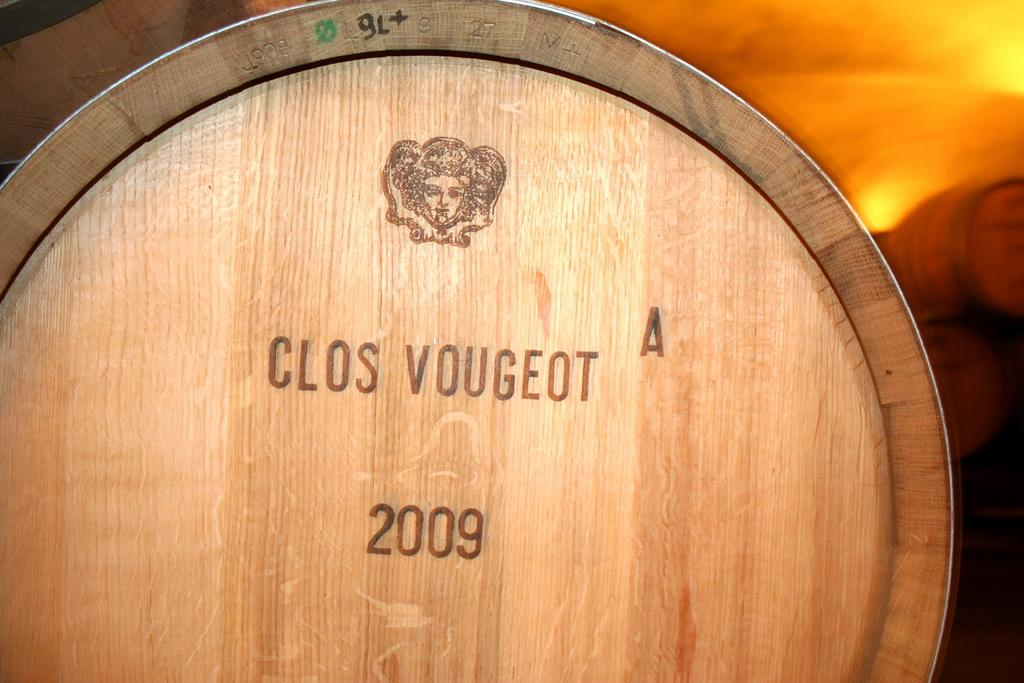<image>
Render a clear and concise summary of the photo. a barrel that says 'clos vougeot 2009' on it 